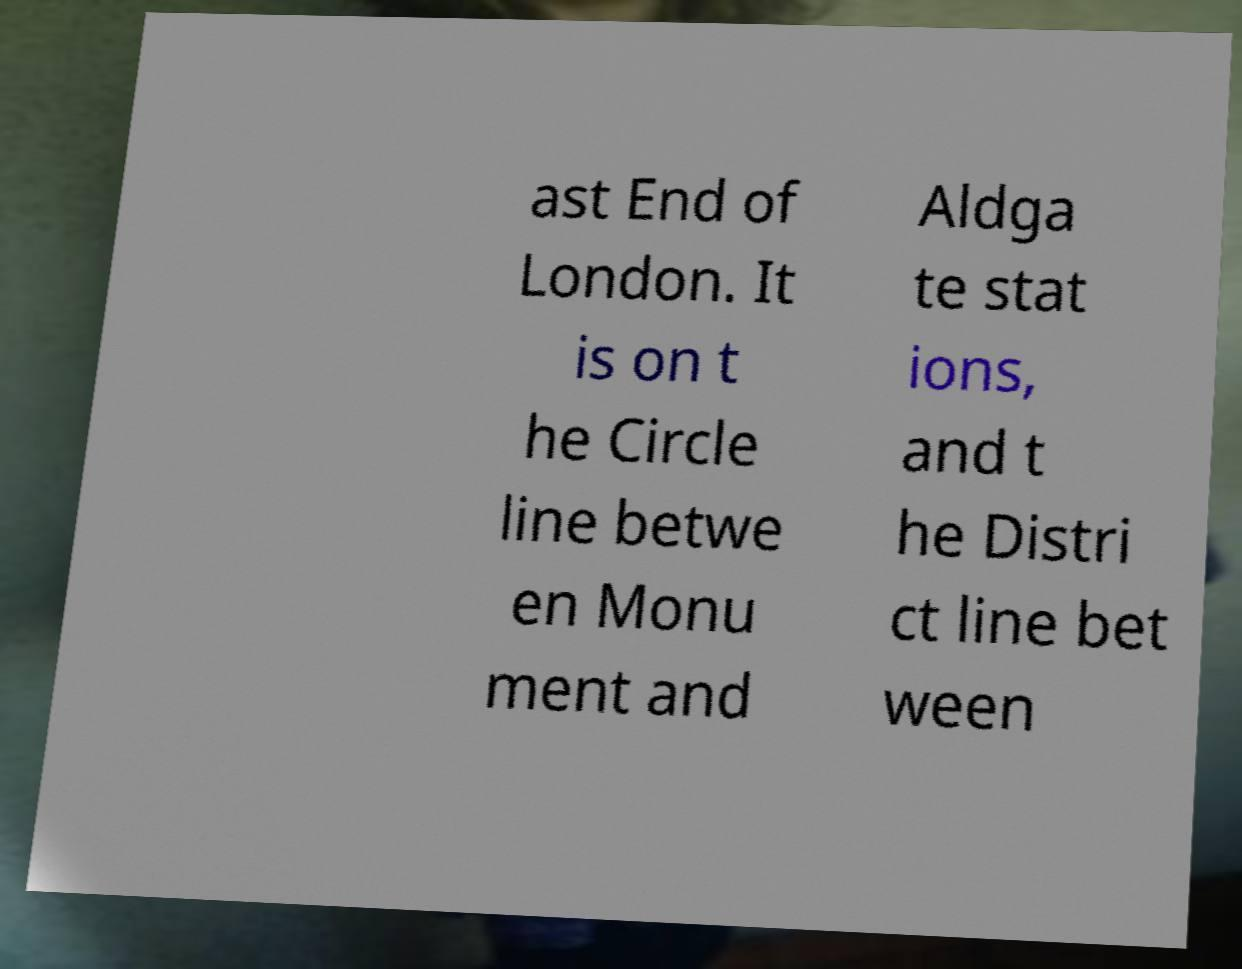Please identify and transcribe the text found in this image. ast End of London. It is on t he Circle line betwe en Monu ment and Aldga te stat ions, and t he Distri ct line bet ween 